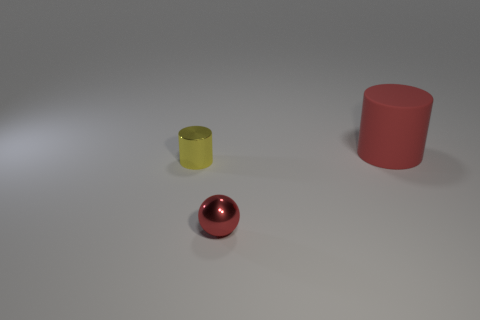What material do the objects in the image look like they are made of? The objects in the image appear to be made of different materials. The red sphere looks like it could be a polished metal due to its reflective surface, while the red and yellow cylinders seem to be made of a matte plastic or rubber based on their less reflective surfaces. 